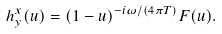<formula> <loc_0><loc_0><loc_500><loc_500>h ^ { x } _ { y } ( u ) = ( 1 - u ) ^ { - i \omega / ( 4 \pi T ) } F ( u ) .</formula> 